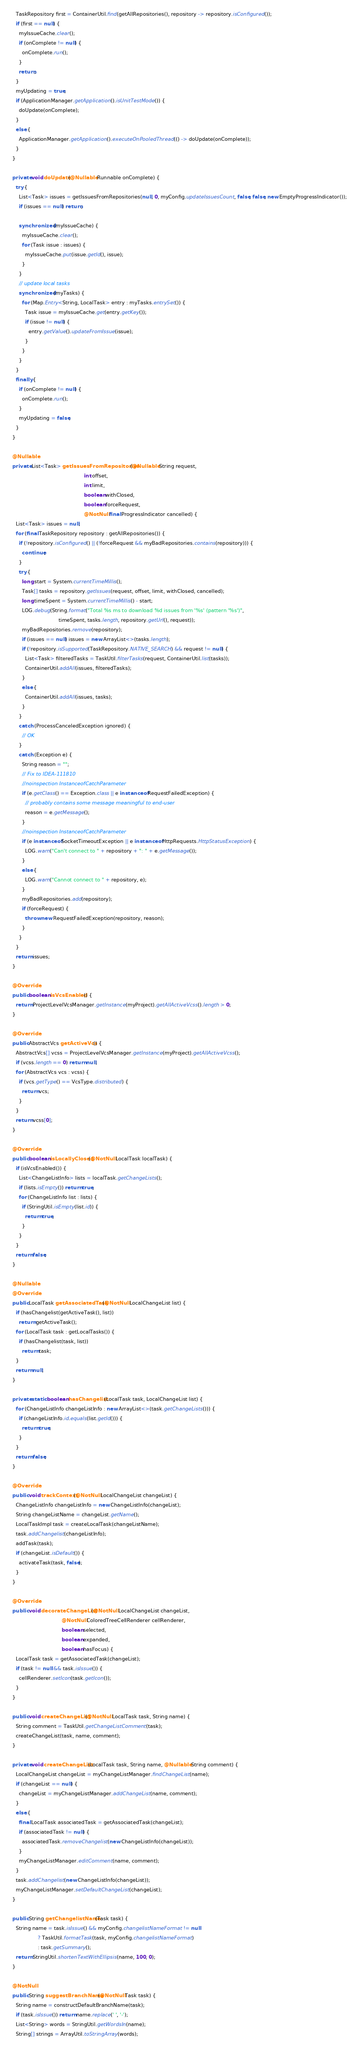Convert code to text. <code><loc_0><loc_0><loc_500><loc_500><_Java_>    TaskRepository first = ContainerUtil.find(getAllRepositories(), repository -> repository.isConfigured());
    if (first == null) {
      myIssueCache.clear();
      if (onComplete != null) {
        onComplete.run();
      }
      return;
    }
    myUpdating = true;
    if (ApplicationManager.getApplication().isUnitTestMode()) {
      doUpdate(onComplete);
    }
    else {
      ApplicationManager.getApplication().executeOnPooledThread(() -> doUpdate(onComplete));
    }
  }

  private void doUpdate(@Nullable Runnable onComplete) {
    try {
      List<Task> issues = getIssuesFromRepositories(null, 0, myConfig.updateIssuesCount, false, false, new EmptyProgressIndicator());
      if (issues == null) return;

      synchronized (myIssueCache) {
        myIssueCache.clear();
        for (Task issue : issues) {
          myIssueCache.put(issue.getId(), issue);
        }
      }
      // update local tasks
      synchronized (myTasks) {
        for (Map.Entry<String, LocalTask> entry : myTasks.entrySet()) {
          Task issue = myIssueCache.get(entry.getKey());
          if (issue != null) {
            entry.getValue().updateFromIssue(issue);
          }
        }
      }
    }
    finally {
      if (onComplete != null) {
        onComplete.run();
      }
      myUpdating = false;
    }
  }

  @Nullable
  private List<Task> getIssuesFromRepositories(@Nullable String request,
                                               int offset,
                                               int limit,
                                               boolean withClosed,
                                               boolean forceRequest,
                                               @NotNull final ProgressIndicator cancelled) {
    List<Task> issues = null;
    for (final TaskRepository repository : getAllRepositories()) {
      if (!repository.isConfigured() || (!forceRequest && myBadRepositories.contains(repository))) {
        continue;
      }
      try {
        long start = System.currentTimeMillis();
        Task[] tasks = repository.getIssues(request, offset, limit, withClosed, cancelled);
        long timeSpent = System.currentTimeMillis() - start;
        LOG.debug(String.format("Total %s ms to download %d issues from '%s' (pattern '%s')",
                               timeSpent, tasks.length, repository.getUrl(), request));
        myBadRepositories.remove(repository);
        if (issues == null) issues = new ArrayList<>(tasks.length);
        if (!repository.isSupported(TaskRepository.NATIVE_SEARCH) && request != null) {
          List<Task> filteredTasks = TaskUtil.filterTasks(request, ContainerUtil.list(tasks));
          ContainerUtil.addAll(issues, filteredTasks);
        }
        else {
          ContainerUtil.addAll(issues, tasks);
        }
      }
      catch (ProcessCanceledException ignored) {
        // OK
      }
      catch (Exception e) {
        String reason = "";
        // Fix to IDEA-111810
        //noinspection InstanceofCatchParameter
        if (e.getClass() == Exception.class || e instanceof RequestFailedException) {
          // probably contains some message meaningful to end-user
          reason = e.getMessage();
        }
        //noinspection InstanceofCatchParameter
        if (e instanceof SocketTimeoutException || e instanceof HttpRequests.HttpStatusException) {
          LOG.warn("Can't connect to " + repository + ": " + e.getMessage());
        }
        else {
          LOG.warn("Cannot connect to " + repository, e);
        }
        myBadRepositories.add(repository);
        if (forceRequest) {
          throw new RequestFailedException(repository, reason);
        }
      }
    }
    return issues;
  }

  @Override
  public boolean isVcsEnabled() {
    return ProjectLevelVcsManager.getInstance(myProject).getAllActiveVcss().length > 0;
  }

  @Override
  public AbstractVcs getActiveVcs() {
    AbstractVcs[] vcss = ProjectLevelVcsManager.getInstance(myProject).getAllActiveVcss();
    if (vcss.length == 0) return null;
    for (AbstractVcs vcs : vcss) {
      if (vcs.getType() == VcsType.distributed) {
        return vcs;
      }
    }
    return vcss[0];
  }

  @Override
  public boolean isLocallyClosed(@NotNull LocalTask localTask) {
    if (isVcsEnabled()) {
      List<ChangeListInfo> lists = localTask.getChangeLists();
      if (lists.isEmpty()) return true;
      for (ChangeListInfo list : lists) {
        if (StringUtil.isEmpty(list.id)) {
          return true;
        }
      }
    }
    return false;
  }

  @Nullable
  @Override
  public LocalTask getAssociatedTask(@NotNull LocalChangeList list) {
    if (hasChangelist(getActiveTask(), list))
      return getActiveTask();
    for (LocalTask task : getLocalTasks()) {
      if (hasChangelist(task, list))
        return task;
    }
    return null;
  }

  private static boolean hasChangelist(LocalTask task, LocalChangeList list) {
    for (ChangeListInfo changeListInfo : new ArrayList<>(task.getChangeLists())) {
      if (changeListInfo.id.equals(list.getId())) {
        return true;
      }
    }
    return false;
  }

  @Override
  public void trackContext(@NotNull LocalChangeList changeList) {
    ChangeListInfo changeListInfo = new ChangeListInfo(changeList);
    String changeListName = changeList.getName();
    LocalTaskImpl task = createLocalTask(changeListName);
    task.addChangelist(changeListInfo);
    addTask(task);
    if (changeList.isDefault()) {
      activateTask(task, false);
    }
  }

  @Override
  public void decorateChangeList(@NotNull LocalChangeList changeList,
                                 @NotNull ColoredTreeCellRenderer cellRenderer,
                                 boolean selected,
                                 boolean expanded,
                                 boolean hasFocus) {
    LocalTask task = getAssociatedTask(changeList);
    if (task != null && task.isIssue()) {
      cellRenderer.setIcon(task.getIcon());
    }
  }

  public void createChangeList(@NotNull LocalTask task, String name) {
    String comment = TaskUtil.getChangeListComment(task);
    createChangeList(task, name, comment);
  }

  private void createChangeList(LocalTask task, String name, @Nullable String comment) {
    LocalChangeList changeList = myChangeListManager.findChangeList(name);
    if (changeList == null) {
      changeList = myChangeListManager.addChangeList(name, comment);
    }
    else {
      final LocalTask associatedTask = getAssociatedTask(changeList);
      if (associatedTask != null) {
        associatedTask.removeChangelist(new ChangeListInfo(changeList));
      }
      myChangeListManager.editComment(name, comment);
    }
    task.addChangelist(new ChangeListInfo(changeList));
    myChangeListManager.setDefaultChangeList(changeList);
  }

  public String getChangelistName(Task task) {
    String name = task.isIssue() && myConfig.changelistNameFormat != null
                  ? TaskUtil.formatTask(task, myConfig.changelistNameFormat)
                  : task.getSummary();
    return StringUtil.shortenTextWithEllipsis(name, 100, 0);
  }

  @NotNull
  public String suggestBranchName(@NotNull Task task) {
    String name = constructDefaultBranchName(task);
    if (task.isIssue()) return name.replace(' ', '-');
    List<String> words = StringUtil.getWordsIn(name);
    String[] strings = ArrayUtil.toStringArray(words);</code> 